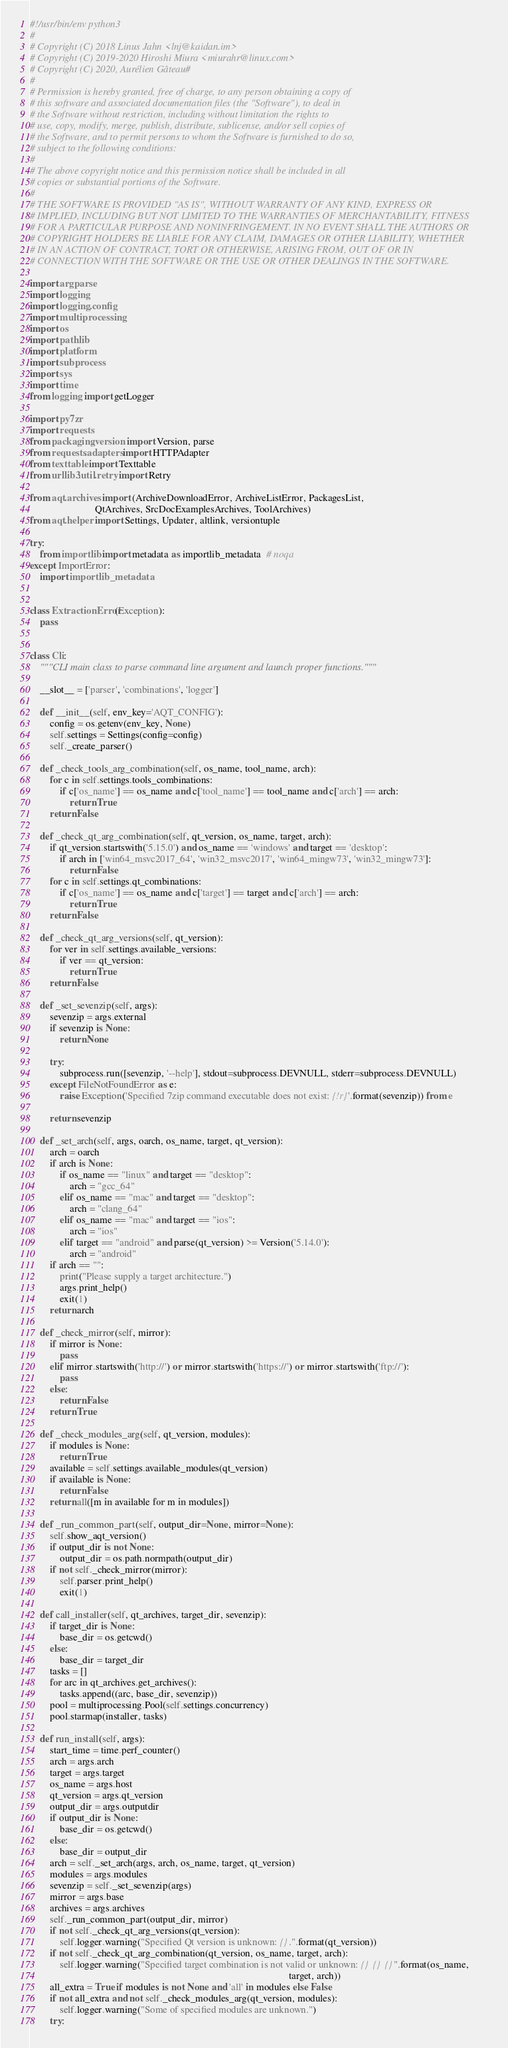Convert code to text. <code><loc_0><loc_0><loc_500><loc_500><_Python_>#!/usr/bin/env python3
#
# Copyright (C) 2018 Linus Jahn <lnj@kaidan.im>
# Copyright (C) 2019-2020 Hiroshi Miura <miurahr@linux.com>
# Copyright (C) 2020, Aurélien Gâteau#
#
# Permission is hereby granted, free of charge, to any person obtaining a copy of
# this software and associated documentation files (the "Software"), to deal in
# the Software without restriction, including without limitation the rights to
# use, copy, modify, merge, publish, distribute, sublicense, and/or sell copies of
# the Software, and to permit persons to whom the Software is furnished to do so,
# subject to the following conditions:
#
# The above copyright notice and this permission notice shall be included in all
# copies or substantial portions of the Software.
#
# THE SOFTWARE IS PROVIDED "AS IS", WITHOUT WARRANTY OF ANY KIND, EXPRESS OR
# IMPLIED, INCLUDING BUT NOT LIMITED TO THE WARRANTIES OF MERCHANTABILITY, FITNESS
# FOR A PARTICULAR PURPOSE AND NONINFRINGEMENT. IN NO EVENT SHALL THE AUTHORS OR
# COPYRIGHT HOLDERS BE LIABLE FOR ANY CLAIM, DAMAGES OR OTHER LIABILITY, WHETHER
# IN AN ACTION OF CONTRACT, TORT OR OTHERWISE, ARISING FROM, OUT OF OR IN
# CONNECTION WITH THE SOFTWARE OR THE USE OR OTHER DEALINGS IN THE SOFTWARE.

import argparse
import logging
import logging.config
import multiprocessing
import os
import pathlib
import platform
import subprocess
import sys
import time
from logging import getLogger

import py7zr
import requests
from packaging.version import Version, parse
from requests.adapters import HTTPAdapter
from texttable import Texttable
from urllib3.util.retry import Retry

from aqt.archives import (ArchiveDownloadError, ArchiveListError, PackagesList,
                          QtArchives, SrcDocExamplesArchives, ToolArchives)
from aqt.helper import Settings, Updater, altlink, versiontuple

try:
    from importlib import metadata as importlib_metadata  # noqa
except ImportError:
    import importlib_metadata


class ExtractionError(Exception):
    pass


class Cli:
    """CLI main class to parse command line argument and launch proper functions."""

    __slot__ = ['parser', 'combinations', 'logger']

    def __init__(self, env_key='AQT_CONFIG'):
        config = os.getenv(env_key, None)
        self.settings = Settings(config=config)
        self._create_parser()

    def _check_tools_arg_combination(self, os_name, tool_name, arch):
        for c in self.settings.tools_combinations:
            if c['os_name'] == os_name and c['tool_name'] == tool_name and c['arch'] == arch:
                return True
        return False

    def _check_qt_arg_combination(self, qt_version, os_name, target, arch):
        if qt_version.startswith('5.15.0') and os_name == 'windows' and target == 'desktop':
            if arch in ['win64_msvc2017_64', 'win32_msvc2017', 'win64_mingw73', 'win32_mingw73']:
                return False
        for c in self.settings.qt_combinations:
            if c['os_name'] == os_name and c['target'] == target and c['arch'] == arch:
                return True
        return False

    def _check_qt_arg_versions(self, qt_version):
        for ver in self.settings.available_versions:
            if ver == qt_version:
                return True
        return False

    def _set_sevenzip(self, args):
        sevenzip = args.external
        if sevenzip is None:
            return None

        try:
            subprocess.run([sevenzip, '--help'], stdout=subprocess.DEVNULL, stderr=subprocess.DEVNULL)
        except FileNotFoundError as e:
            raise Exception('Specified 7zip command executable does not exist: {!r}'.format(sevenzip)) from e

        return sevenzip

    def _set_arch(self, args, oarch, os_name, target, qt_version):
        arch = oarch
        if arch is None:
            if os_name == "linux" and target == "desktop":
                arch = "gcc_64"
            elif os_name == "mac" and target == "desktop":
                arch = "clang_64"
            elif os_name == "mac" and target == "ios":
                arch = "ios"
            elif target == "android" and parse(qt_version) >= Version('5.14.0'):
                arch = "android"
        if arch == "":
            print("Please supply a target architecture.")
            args.print_help()
            exit(1)
        return arch

    def _check_mirror(self, mirror):
        if mirror is None:
            pass
        elif mirror.startswith('http://') or mirror.startswith('https://') or mirror.startswith('ftp://'):
            pass
        else:
            return False
        return True

    def _check_modules_arg(self, qt_version, modules):
        if modules is None:
            return True
        available = self.settings.available_modules(qt_version)
        if available is None:
            return False
        return all([m in available for m in modules])

    def _run_common_part(self, output_dir=None, mirror=None):
        self.show_aqt_version()
        if output_dir is not None:
            output_dir = os.path.normpath(output_dir)
        if not self._check_mirror(mirror):
            self.parser.print_help()
            exit(1)

    def call_installer(self, qt_archives, target_dir, sevenzip):
        if target_dir is None:
            base_dir = os.getcwd()
        else:
            base_dir = target_dir
        tasks = []
        for arc in qt_archives.get_archives():
            tasks.append((arc, base_dir, sevenzip))
        pool = multiprocessing.Pool(self.settings.concurrency)
        pool.starmap(installer, tasks)

    def run_install(self, args):
        start_time = time.perf_counter()
        arch = args.arch
        target = args.target
        os_name = args.host
        qt_version = args.qt_version
        output_dir = args.outputdir
        if output_dir is None:
            base_dir = os.getcwd()
        else:
            base_dir = output_dir
        arch = self._set_arch(args, arch, os_name, target, qt_version)
        modules = args.modules
        sevenzip = self._set_sevenzip(args)
        mirror = args.base
        archives = args.archives
        self._run_common_part(output_dir, mirror)
        if not self._check_qt_arg_versions(qt_version):
            self.logger.warning("Specified Qt version is unknown: {}.".format(qt_version))
        if not self._check_qt_arg_combination(qt_version, os_name, target, arch):
            self.logger.warning("Specified target combination is not valid or unknown: {} {} {}".format(os_name,
                                                                                                        target, arch))
        all_extra = True if modules is not None and 'all' in modules else False
        if not all_extra and not self._check_modules_arg(qt_version, modules):
            self.logger.warning("Some of specified modules are unknown.")
        try:</code> 